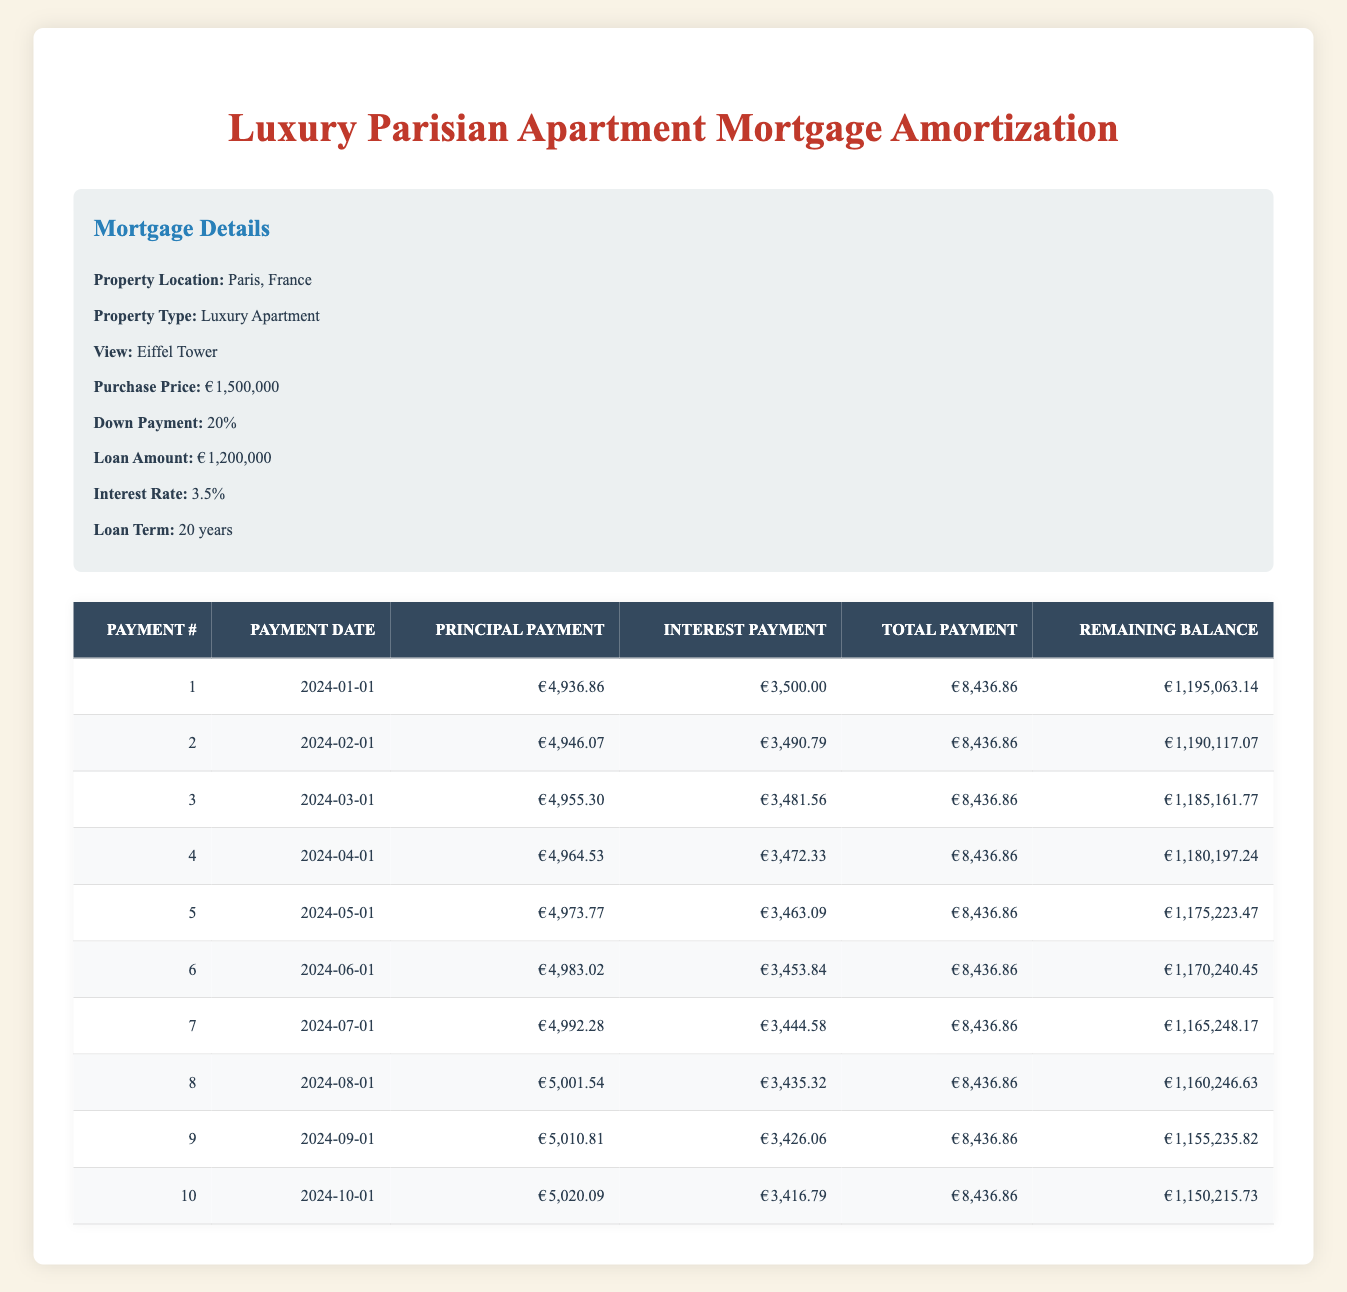What is the total payment for the first installment? The first installment, identified by payment number 1 in the table, shows a total payment value of 8436.86.
Answer: 8436.86 How much principal is paid off in the second payment? The second payment, indicated by payment number 2, has a principal payment of 4946.07.
Answer: 4946.07 What is the remaining balance after the fifth payment? Referring to the table, after the fifth payment, the remaining balance listed is 1175223.47.
Answer: 1175223.47 Is the interest payment for the fourth installment greater than that of the first installment? The interest payment for the fourth installment is 3472.33, while the first installment's interest payment is 3500.00. Since 3472.33 is less than 3500.00, the statement is false.
Answer: No What is the total principal paid off in the first three payments? To find the total principal paid off, sum the principal payments of the first three payment rows: 4936.86 + 4946.07 + 4955.30 = 14838.23.
Answer: 14838.23 What is the difference in interest payments between the sixth and seventh installments? The interest payment of the sixth installment is 3453.84 and for the seventh is 3444.58. The difference is 3453.84 - 3444.58 = 9.26.
Answer: 9.26 What is the average total payment over the first ten installments? The total payment for each installment is 8436.86, repeated over ten installments. Thus, the average total payment is (8436.86 * 10) / 10 = 8436.86.
Answer: 8436.86 How much does the remaining balance decrease from the first to the tenth payment? The remaining balance after the first payment is 1195063.14, and after the tenth payment, it's 1150215.73. The decrease is 1195063.14 - 1150215.73 = 44847.41.
Answer: 44847.41 Is the principal payment for the third installment more than 4950? The principal payment for the third installment is 4955.30, which is greater than 4950. Therefore, the statement is true.
Answer: Yes 